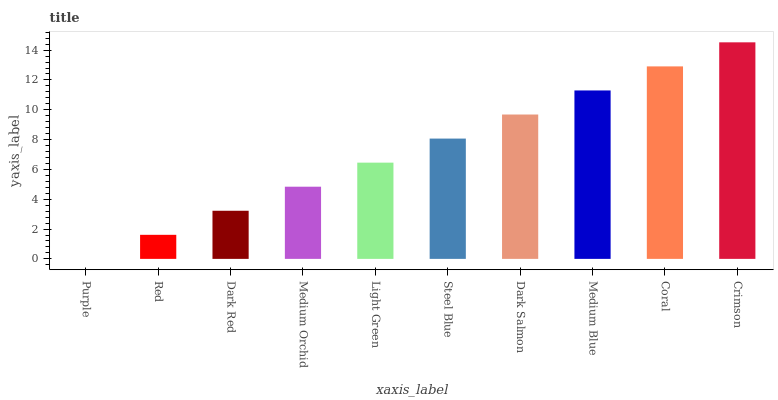Is Purple the minimum?
Answer yes or no. Yes. Is Crimson the maximum?
Answer yes or no. Yes. Is Red the minimum?
Answer yes or no. No. Is Red the maximum?
Answer yes or no. No. Is Red greater than Purple?
Answer yes or no. Yes. Is Purple less than Red?
Answer yes or no. Yes. Is Purple greater than Red?
Answer yes or no. No. Is Red less than Purple?
Answer yes or no. No. Is Steel Blue the high median?
Answer yes or no. Yes. Is Light Green the low median?
Answer yes or no. Yes. Is Purple the high median?
Answer yes or no. No. Is Dark Salmon the low median?
Answer yes or no. No. 